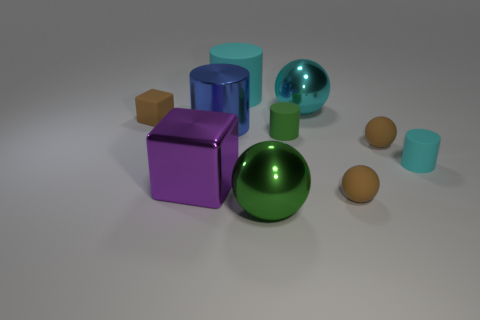There is a cyan thing that is the same shape as the big green thing; what is it made of?
Provide a short and direct response. Metal. Are there any other things that have the same material as the green cylinder?
Offer a terse response. Yes. Are there any green things to the left of the big blue cylinder?
Make the answer very short. No. How many small gray metallic objects are there?
Your answer should be compact. 0. What number of small brown objects are on the right side of the matte thing that is behind the tiny brown matte cube?
Ensure brevity in your answer.  2. Do the big metal block and the large metallic sphere behind the large blue metal cylinder have the same color?
Ensure brevity in your answer.  No. How many other tiny objects have the same shape as the green matte object?
Your answer should be very brief. 1. What material is the tiny brown sphere in front of the small cyan matte cylinder?
Offer a very short reply. Rubber. There is a small rubber thing on the left side of the blue cylinder; is its shape the same as the tiny cyan object?
Your answer should be very brief. No. Are there any objects that have the same size as the green matte cylinder?
Provide a short and direct response. Yes. 